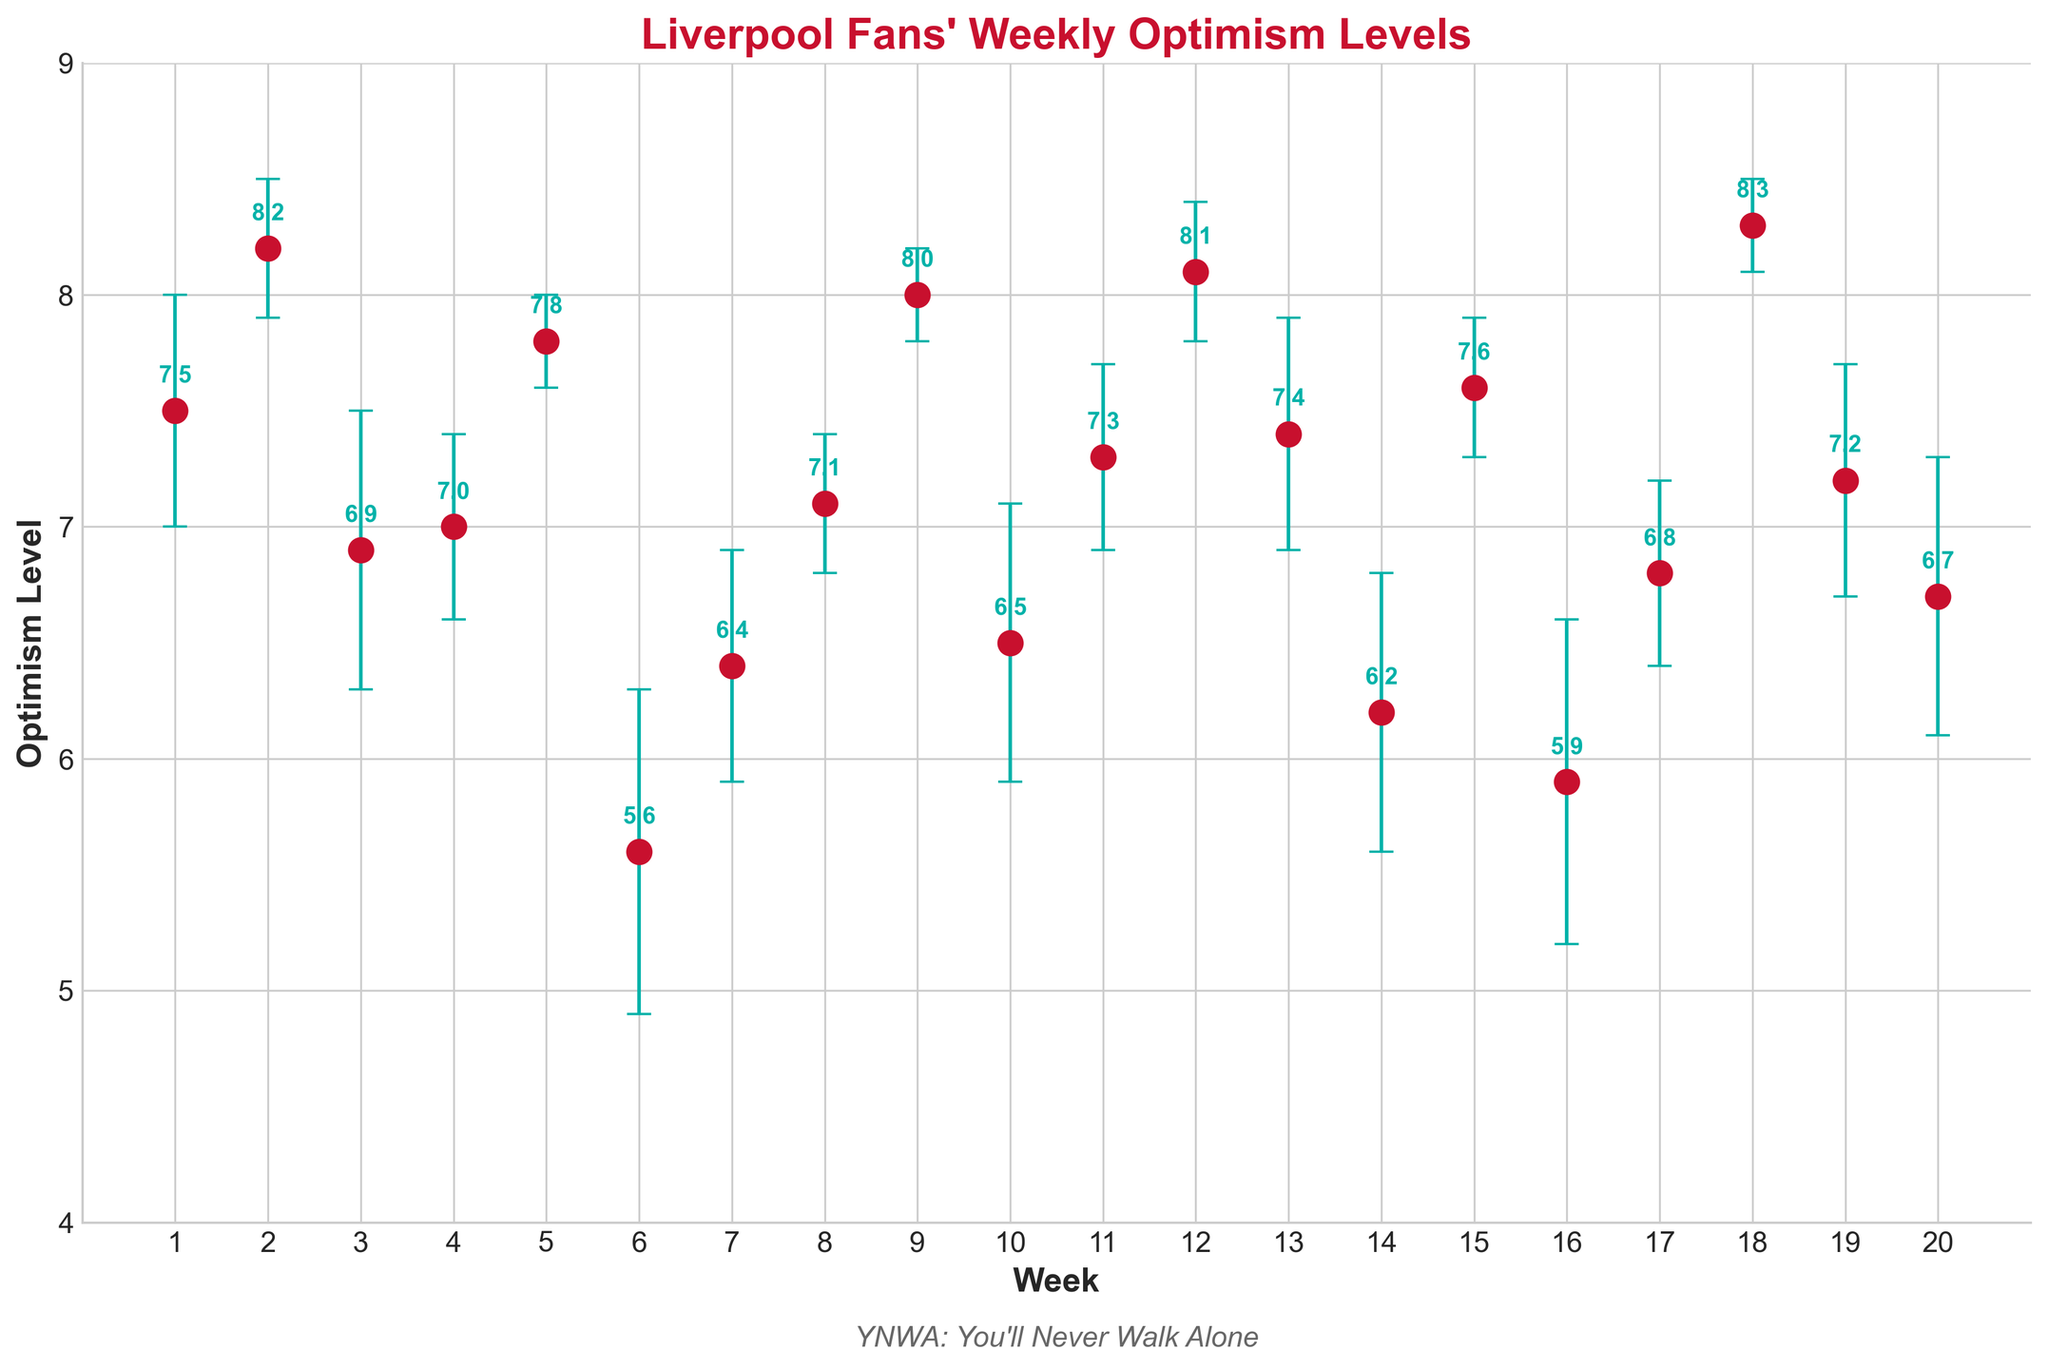How many weeks are displayed in the plot? The x-axis labels display numbers indicating the weeks. Counting them from 1 to 20 gives us the total number of weeks displayed.
Answer: 20 What is the title of the plot? The title is typically located at the top of the plot in larger and bold font.
Answer: Liverpool Fans' Weekly Optimism Levels What are the units on the y-axis? The y-axis labels represent the units of optimism levels. They range from 4 to 9 and are described as "Optimism Level."
Answer: Optimism Level What is the optimism level during Week 9? Locate Week 9 on the x-axis and find the corresponding dot. The associated optimism level is displayed next to the dot.
Answer: 8.0 During which week was the optimism level the highest? Scan through the chart to find the dot that is at the highest vertical position on the y-axis. The week level for that dot is the answer.
Answer: 18 Which week had the largest variance in optimism level? Observing the error bars (the vertical lines above and below the dots), determine the week with the longest error bar.
Answer: 6 How does Week 12's optimism level compare to Week 6's level? Compare the positions of dots for Week 12 and Week 6 on the y-axis. Week 12's dot is higher than Week 6's dot.
Answer: Week 12's optimism level is higher What was the average optimism level for the first 5 weeks? Add the optimism levels for Weeks 1 through 5 and divide by 5: (7.5 + 8.2 + 6.9 + 7.0 + 7.8)/5
Answer: 7.48 What's the difference in optimism levels between Week 19 and Week 10? Locate the optimism levels for Week 19 and Week 10 and subtract the latter from the former: 7.2 - 6.5
Answer: 0.7 What is the trend of optimism levels from Week 17 to Week 18? By comparing the Week 17 and Week 18 dots on the y-axis, observe whether the level increases, decreases, or stays the same.
Answer: Increase 